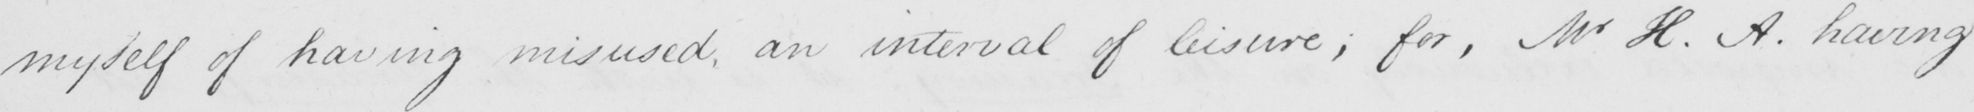Please transcribe the handwritten text in this image. myself of having misused , an interval of leisure ; for , Mr H . A . having 